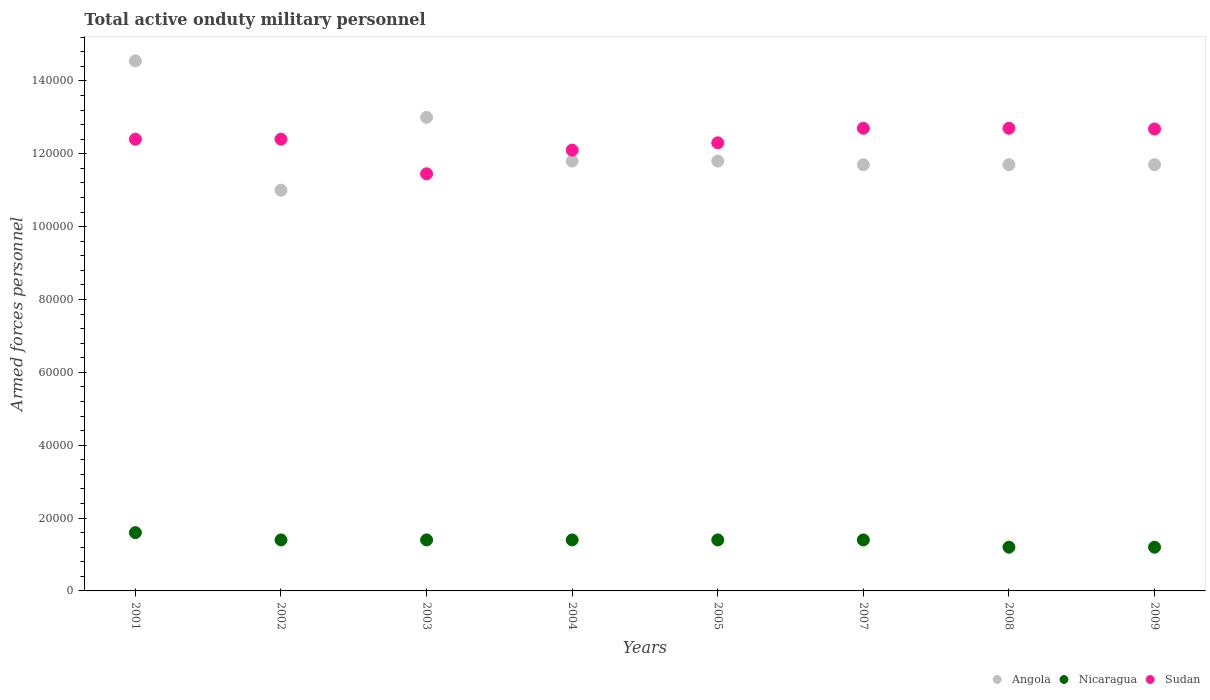How many different coloured dotlines are there?
Offer a very short reply. 3. Is the number of dotlines equal to the number of legend labels?
Offer a terse response. Yes. What is the number of armed forces personnel in Nicaragua in 2007?
Ensure brevity in your answer.  1.40e+04. Across all years, what is the maximum number of armed forces personnel in Sudan?
Provide a succinct answer. 1.27e+05. Across all years, what is the minimum number of armed forces personnel in Sudan?
Make the answer very short. 1.14e+05. In which year was the number of armed forces personnel in Angola maximum?
Provide a short and direct response. 2001. In which year was the number of armed forces personnel in Sudan minimum?
Offer a very short reply. 2003. What is the total number of armed forces personnel in Sudan in the graph?
Offer a terse response. 9.87e+05. What is the difference between the number of armed forces personnel in Sudan in 2001 and that in 2007?
Offer a very short reply. -3000. What is the difference between the number of armed forces personnel in Sudan in 2002 and the number of armed forces personnel in Nicaragua in 2001?
Ensure brevity in your answer.  1.08e+05. What is the average number of armed forces personnel in Sudan per year?
Keep it short and to the point. 1.23e+05. In the year 2003, what is the difference between the number of armed forces personnel in Sudan and number of armed forces personnel in Nicaragua?
Provide a short and direct response. 1.00e+05. What is the ratio of the number of armed forces personnel in Angola in 2003 to that in 2008?
Your response must be concise. 1.11. Is the number of armed forces personnel in Sudan in 2002 less than that in 2009?
Your response must be concise. Yes. Is the difference between the number of armed forces personnel in Sudan in 2005 and 2007 greater than the difference between the number of armed forces personnel in Nicaragua in 2005 and 2007?
Your answer should be compact. No. What is the difference between the highest and the lowest number of armed forces personnel in Sudan?
Your answer should be compact. 1.25e+04. Does the number of armed forces personnel in Nicaragua monotonically increase over the years?
Offer a terse response. No. Is the number of armed forces personnel in Nicaragua strictly greater than the number of armed forces personnel in Angola over the years?
Ensure brevity in your answer.  No. How many dotlines are there?
Provide a succinct answer. 3. How many years are there in the graph?
Your answer should be very brief. 8. What is the difference between two consecutive major ticks on the Y-axis?
Give a very brief answer. 2.00e+04. Are the values on the major ticks of Y-axis written in scientific E-notation?
Give a very brief answer. No. Does the graph contain any zero values?
Give a very brief answer. No. What is the title of the graph?
Make the answer very short. Total active onduty military personnel. What is the label or title of the X-axis?
Keep it short and to the point. Years. What is the label or title of the Y-axis?
Your answer should be compact. Armed forces personnel. What is the Armed forces personnel in Angola in 2001?
Your answer should be compact. 1.46e+05. What is the Armed forces personnel in Nicaragua in 2001?
Provide a short and direct response. 1.60e+04. What is the Armed forces personnel in Sudan in 2001?
Your answer should be compact. 1.24e+05. What is the Armed forces personnel in Angola in 2002?
Keep it short and to the point. 1.10e+05. What is the Armed forces personnel in Nicaragua in 2002?
Make the answer very short. 1.40e+04. What is the Armed forces personnel of Sudan in 2002?
Keep it short and to the point. 1.24e+05. What is the Armed forces personnel of Nicaragua in 2003?
Your response must be concise. 1.40e+04. What is the Armed forces personnel of Sudan in 2003?
Offer a very short reply. 1.14e+05. What is the Armed forces personnel in Angola in 2004?
Your answer should be very brief. 1.18e+05. What is the Armed forces personnel in Nicaragua in 2004?
Keep it short and to the point. 1.40e+04. What is the Armed forces personnel of Sudan in 2004?
Keep it short and to the point. 1.21e+05. What is the Armed forces personnel in Angola in 2005?
Offer a terse response. 1.18e+05. What is the Armed forces personnel of Nicaragua in 2005?
Your answer should be very brief. 1.40e+04. What is the Armed forces personnel of Sudan in 2005?
Offer a very short reply. 1.23e+05. What is the Armed forces personnel in Angola in 2007?
Provide a short and direct response. 1.17e+05. What is the Armed forces personnel of Nicaragua in 2007?
Keep it short and to the point. 1.40e+04. What is the Armed forces personnel in Sudan in 2007?
Offer a terse response. 1.27e+05. What is the Armed forces personnel of Angola in 2008?
Offer a terse response. 1.17e+05. What is the Armed forces personnel in Nicaragua in 2008?
Provide a succinct answer. 1.20e+04. What is the Armed forces personnel in Sudan in 2008?
Offer a terse response. 1.27e+05. What is the Armed forces personnel in Angola in 2009?
Offer a terse response. 1.17e+05. What is the Armed forces personnel in Nicaragua in 2009?
Ensure brevity in your answer.  1.20e+04. What is the Armed forces personnel of Sudan in 2009?
Keep it short and to the point. 1.27e+05. Across all years, what is the maximum Armed forces personnel of Angola?
Ensure brevity in your answer.  1.46e+05. Across all years, what is the maximum Armed forces personnel of Nicaragua?
Ensure brevity in your answer.  1.60e+04. Across all years, what is the maximum Armed forces personnel in Sudan?
Your answer should be very brief. 1.27e+05. Across all years, what is the minimum Armed forces personnel of Angola?
Your answer should be very brief. 1.10e+05. Across all years, what is the minimum Armed forces personnel in Nicaragua?
Provide a succinct answer. 1.20e+04. Across all years, what is the minimum Armed forces personnel of Sudan?
Your answer should be very brief. 1.14e+05. What is the total Armed forces personnel of Angola in the graph?
Your answer should be compact. 9.72e+05. What is the total Armed forces personnel in Nicaragua in the graph?
Your response must be concise. 1.10e+05. What is the total Armed forces personnel of Sudan in the graph?
Your answer should be compact. 9.87e+05. What is the difference between the Armed forces personnel in Angola in 2001 and that in 2002?
Provide a short and direct response. 3.55e+04. What is the difference between the Armed forces personnel in Angola in 2001 and that in 2003?
Keep it short and to the point. 1.55e+04. What is the difference between the Armed forces personnel in Sudan in 2001 and that in 2003?
Your answer should be compact. 9500. What is the difference between the Armed forces personnel of Angola in 2001 and that in 2004?
Provide a short and direct response. 2.75e+04. What is the difference between the Armed forces personnel of Nicaragua in 2001 and that in 2004?
Your answer should be very brief. 2000. What is the difference between the Armed forces personnel in Sudan in 2001 and that in 2004?
Give a very brief answer. 3000. What is the difference between the Armed forces personnel of Angola in 2001 and that in 2005?
Offer a terse response. 2.75e+04. What is the difference between the Armed forces personnel of Sudan in 2001 and that in 2005?
Offer a terse response. 1000. What is the difference between the Armed forces personnel in Angola in 2001 and that in 2007?
Your answer should be compact. 2.85e+04. What is the difference between the Armed forces personnel in Sudan in 2001 and that in 2007?
Provide a succinct answer. -3000. What is the difference between the Armed forces personnel in Angola in 2001 and that in 2008?
Give a very brief answer. 2.85e+04. What is the difference between the Armed forces personnel in Nicaragua in 2001 and that in 2008?
Provide a short and direct response. 4000. What is the difference between the Armed forces personnel in Sudan in 2001 and that in 2008?
Offer a terse response. -3000. What is the difference between the Armed forces personnel in Angola in 2001 and that in 2009?
Provide a succinct answer. 2.85e+04. What is the difference between the Armed forces personnel in Nicaragua in 2001 and that in 2009?
Offer a terse response. 4000. What is the difference between the Armed forces personnel of Sudan in 2001 and that in 2009?
Provide a succinct answer. -2800. What is the difference between the Armed forces personnel in Angola in 2002 and that in 2003?
Your response must be concise. -2.00e+04. What is the difference between the Armed forces personnel of Nicaragua in 2002 and that in 2003?
Provide a succinct answer. 0. What is the difference between the Armed forces personnel of Sudan in 2002 and that in 2003?
Make the answer very short. 9500. What is the difference between the Armed forces personnel in Angola in 2002 and that in 2004?
Your answer should be compact. -8000. What is the difference between the Armed forces personnel of Nicaragua in 2002 and that in 2004?
Keep it short and to the point. 0. What is the difference between the Armed forces personnel of Sudan in 2002 and that in 2004?
Your answer should be compact. 3000. What is the difference between the Armed forces personnel of Angola in 2002 and that in 2005?
Give a very brief answer. -8000. What is the difference between the Armed forces personnel of Sudan in 2002 and that in 2005?
Keep it short and to the point. 1000. What is the difference between the Armed forces personnel in Angola in 2002 and that in 2007?
Keep it short and to the point. -7000. What is the difference between the Armed forces personnel of Sudan in 2002 and that in 2007?
Provide a short and direct response. -3000. What is the difference between the Armed forces personnel of Angola in 2002 and that in 2008?
Your answer should be compact. -7000. What is the difference between the Armed forces personnel of Sudan in 2002 and that in 2008?
Ensure brevity in your answer.  -3000. What is the difference between the Armed forces personnel in Angola in 2002 and that in 2009?
Keep it short and to the point. -7000. What is the difference between the Armed forces personnel of Nicaragua in 2002 and that in 2009?
Provide a short and direct response. 2000. What is the difference between the Armed forces personnel in Sudan in 2002 and that in 2009?
Offer a terse response. -2800. What is the difference between the Armed forces personnel in Angola in 2003 and that in 2004?
Your response must be concise. 1.20e+04. What is the difference between the Armed forces personnel in Nicaragua in 2003 and that in 2004?
Ensure brevity in your answer.  0. What is the difference between the Armed forces personnel in Sudan in 2003 and that in 2004?
Ensure brevity in your answer.  -6500. What is the difference between the Armed forces personnel in Angola in 2003 and that in 2005?
Ensure brevity in your answer.  1.20e+04. What is the difference between the Armed forces personnel of Nicaragua in 2003 and that in 2005?
Provide a short and direct response. 0. What is the difference between the Armed forces personnel in Sudan in 2003 and that in 2005?
Your answer should be compact. -8500. What is the difference between the Armed forces personnel of Angola in 2003 and that in 2007?
Give a very brief answer. 1.30e+04. What is the difference between the Armed forces personnel of Nicaragua in 2003 and that in 2007?
Your answer should be very brief. 0. What is the difference between the Armed forces personnel of Sudan in 2003 and that in 2007?
Your answer should be very brief. -1.25e+04. What is the difference between the Armed forces personnel in Angola in 2003 and that in 2008?
Your response must be concise. 1.30e+04. What is the difference between the Armed forces personnel of Nicaragua in 2003 and that in 2008?
Provide a short and direct response. 2000. What is the difference between the Armed forces personnel in Sudan in 2003 and that in 2008?
Make the answer very short. -1.25e+04. What is the difference between the Armed forces personnel of Angola in 2003 and that in 2009?
Offer a very short reply. 1.30e+04. What is the difference between the Armed forces personnel of Sudan in 2003 and that in 2009?
Your answer should be very brief. -1.23e+04. What is the difference between the Armed forces personnel in Angola in 2004 and that in 2005?
Give a very brief answer. 0. What is the difference between the Armed forces personnel in Nicaragua in 2004 and that in 2005?
Keep it short and to the point. 0. What is the difference between the Armed forces personnel of Sudan in 2004 and that in 2005?
Your response must be concise. -2000. What is the difference between the Armed forces personnel in Angola in 2004 and that in 2007?
Provide a succinct answer. 1000. What is the difference between the Armed forces personnel in Sudan in 2004 and that in 2007?
Provide a succinct answer. -6000. What is the difference between the Armed forces personnel in Sudan in 2004 and that in 2008?
Offer a terse response. -6000. What is the difference between the Armed forces personnel in Angola in 2004 and that in 2009?
Your answer should be very brief. 1000. What is the difference between the Armed forces personnel of Sudan in 2004 and that in 2009?
Your answer should be very brief. -5800. What is the difference between the Armed forces personnel in Nicaragua in 2005 and that in 2007?
Keep it short and to the point. 0. What is the difference between the Armed forces personnel of Sudan in 2005 and that in 2007?
Offer a terse response. -4000. What is the difference between the Armed forces personnel in Nicaragua in 2005 and that in 2008?
Offer a very short reply. 2000. What is the difference between the Armed forces personnel in Sudan in 2005 and that in 2008?
Offer a terse response. -4000. What is the difference between the Armed forces personnel of Nicaragua in 2005 and that in 2009?
Provide a succinct answer. 2000. What is the difference between the Armed forces personnel of Sudan in 2005 and that in 2009?
Give a very brief answer. -3800. What is the difference between the Armed forces personnel in Angola in 2007 and that in 2008?
Your answer should be compact. 0. What is the difference between the Armed forces personnel in Sudan in 2007 and that in 2008?
Offer a very short reply. 0. What is the difference between the Armed forces personnel of Nicaragua in 2007 and that in 2009?
Offer a terse response. 2000. What is the difference between the Armed forces personnel in Sudan in 2007 and that in 2009?
Offer a very short reply. 200. What is the difference between the Armed forces personnel of Nicaragua in 2008 and that in 2009?
Your response must be concise. 0. What is the difference between the Armed forces personnel in Angola in 2001 and the Armed forces personnel in Nicaragua in 2002?
Provide a short and direct response. 1.32e+05. What is the difference between the Armed forces personnel in Angola in 2001 and the Armed forces personnel in Sudan in 2002?
Offer a very short reply. 2.15e+04. What is the difference between the Armed forces personnel in Nicaragua in 2001 and the Armed forces personnel in Sudan in 2002?
Offer a terse response. -1.08e+05. What is the difference between the Armed forces personnel in Angola in 2001 and the Armed forces personnel in Nicaragua in 2003?
Your answer should be very brief. 1.32e+05. What is the difference between the Armed forces personnel in Angola in 2001 and the Armed forces personnel in Sudan in 2003?
Provide a succinct answer. 3.10e+04. What is the difference between the Armed forces personnel of Nicaragua in 2001 and the Armed forces personnel of Sudan in 2003?
Provide a succinct answer. -9.85e+04. What is the difference between the Armed forces personnel of Angola in 2001 and the Armed forces personnel of Nicaragua in 2004?
Your response must be concise. 1.32e+05. What is the difference between the Armed forces personnel of Angola in 2001 and the Armed forces personnel of Sudan in 2004?
Make the answer very short. 2.45e+04. What is the difference between the Armed forces personnel in Nicaragua in 2001 and the Armed forces personnel in Sudan in 2004?
Your response must be concise. -1.05e+05. What is the difference between the Armed forces personnel in Angola in 2001 and the Armed forces personnel in Nicaragua in 2005?
Keep it short and to the point. 1.32e+05. What is the difference between the Armed forces personnel in Angola in 2001 and the Armed forces personnel in Sudan in 2005?
Your response must be concise. 2.25e+04. What is the difference between the Armed forces personnel in Nicaragua in 2001 and the Armed forces personnel in Sudan in 2005?
Offer a terse response. -1.07e+05. What is the difference between the Armed forces personnel of Angola in 2001 and the Armed forces personnel of Nicaragua in 2007?
Ensure brevity in your answer.  1.32e+05. What is the difference between the Armed forces personnel in Angola in 2001 and the Armed forces personnel in Sudan in 2007?
Your response must be concise. 1.85e+04. What is the difference between the Armed forces personnel in Nicaragua in 2001 and the Armed forces personnel in Sudan in 2007?
Your answer should be very brief. -1.11e+05. What is the difference between the Armed forces personnel in Angola in 2001 and the Armed forces personnel in Nicaragua in 2008?
Give a very brief answer. 1.34e+05. What is the difference between the Armed forces personnel of Angola in 2001 and the Armed forces personnel of Sudan in 2008?
Provide a short and direct response. 1.85e+04. What is the difference between the Armed forces personnel in Nicaragua in 2001 and the Armed forces personnel in Sudan in 2008?
Your response must be concise. -1.11e+05. What is the difference between the Armed forces personnel of Angola in 2001 and the Armed forces personnel of Nicaragua in 2009?
Offer a terse response. 1.34e+05. What is the difference between the Armed forces personnel in Angola in 2001 and the Armed forces personnel in Sudan in 2009?
Your response must be concise. 1.87e+04. What is the difference between the Armed forces personnel in Nicaragua in 2001 and the Armed forces personnel in Sudan in 2009?
Give a very brief answer. -1.11e+05. What is the difference between the Armed forces personnel in Angola in 2002 and the Armed forces personnel in Nicaragua in 2003?
Give a very brief answer. 9.60e+04. What is the difference between the Armed forces personnel in Angola in 2002 and the Armed forces personnel in Sudan in 2003?
Give a very brief answer. -4500. What is the difference between the Armed forces personnel of Nicaragua in 2002 and the Armed forces personnel of Sudan in 2003?
Keep it short and to the point. -1.00e+05. What is the difference between the Armed forces personnel of Angola in 2002 and the Armed forces personnel of Nicaragua in 2004?
Ensure brevity in your answer.  9.60e+04. What is the difference between the Armed forces personnel of Angola in 2002 and the Armed forces personnel of Sudan in 2004?
Provide a succinct answer. -1.10e+04. What is the difference between the Armed forces personnel of Nicaragua in 2002 and the Armed forces personnel of Sudan in 2004?
Your answer should be very brief. -1.07e+05. What is the difference between the Armed forces personnel of Angola in 2002 and the Armed forces personnel of Nicaragua in 2005?
Provide a short and direct response. 9.60e+04. What is the difference between the Armed forces personnel in Angola in 2002 and the Armed forces personnel in Sudan in 2005?
Provide a short and direct response. -1.30e+04. What is the difference between the Armed forces personnel in Nicaragua in 2002 and the Armed forces personnel in Sudan in 2005?
Your answer should be very brief. -1.09e+05. What is the difference between the Armed forces personnel of Angola in 2002 and the Armed forces personnel of Nicaragua in 2007?
Make the answer very short. 9.60e+04. What is the difference between the Armed forces personnel in Angola in 2002 and the Armed forces personnel in Sudan in 2007?
Ensure brevity in your answer.  -1.70e+04. What is the difference between the Armed forces personnel of Nicaragua in 2002 and the Armed forces personnel of Sudan in 2007?
Provide a succinct answer. -1.13e+05. What is the difference between the Armed forces personnel of Angola in 2002 and the Armed forces personnel of Nicaragua in 2008?
Provide a short and direct response. 9.80e+04. What is the difference between the Armed forces personnel in Angola in 2002 and the Armed forces personnel in Sudan in 2008?
Provide a succinct answer. -1.70e+04. What is the difference between the Armed forces personnel of Nicaragua in 2002 and the Armed forces personnel of Sudan in 2008?
Ensure brevity in your answer.  -1.13e+05. What is the difference between the Armed forces personnel in Angola in 2002 and the Armed forces personnel in Nicaragua in 2009?
Keep it short and to the point. 9.80e+04. What is the difference between the Armed forces personnel of Angola in 2002 and the Armed forces personnel of Sudan in 2009?
Ensure brevity in your answer.  -1.68e+04. What is the difference between the Armed forces personnel in Nicaragua in 2002 and the Armed forces personnel in Sudan in 2009?
Your response must be concise. -1.13e+05. What is the difference between the Armed forces personnel in Angola in 2003 and the Armed forces personnel in Nicaragua in 2004?
Ensure brevity in your answer.  1.16e+05. What is the difference between the Armed forces personnel in Angola in 2003 and the Armed forces personnel in Sudan in 2004?
Ensure brevity in your answer.  9000. What is the difference between the Armed forces personnel in Nicaragua in 2003 and the Armed forces personnel in Sudan in 2004?
Provide a short and direct response. -1.07e+05. What is the difference between the Armed forces personnel in Angola in 2003 and the Armed forces personnel in Nicaragua in 2005?
Make the answer very short. 1.16e+05. What is the difference between the Armed forces personnel of Angola in 2003 and the Armed forces personnel of Sudan in 2005?
Make the answer very short. 7000. What is the difference between the Armed forces personnel in Nicaragua in 2003 and the Armed forces personnel in Sudan in 2005?
Your response must be concise. -1.09e+05. What is the difference between the Armed forces personnel in Angola in 2003 and the Armed forces personnel in Nicaragua in 2007?
Your response must be concise. 1.16e+05. What is the difference between the Armed forces personnel in Angola in 2003 and the Armed forces personnel in Sudan in 2007?
Provide a succinct answer. 3000. What is the difference between the Armed forces personnel of Nicaragua in 2003 and the Armed forces personnel of Sudan in 2007?
Your answer should be very brief. -1.13e+05. What is the difference between the Armed forces personnel of Angola in 2003 and the Armed forces personnel of Nicaragua in 2008?
Ensure brevity in your answer.  1.18e+05. What is the difference between the Armed forces personnel of Angola in 2003 and the Armed forces personnel of Sudan in 2008?
Offer a very short reply. 3000. What is the difference between the Armed forces personnel of Nicaragua in 2003 and the Armed forces personnel of Sudan in 2008?
Make the answer very short. -1.13e+05. What is the difference between the Armed forces personnel of Angola in 2003 and the Armed forces personnel of Nicaragua in 2009?
Your answer should be very brief. 1.18e+05. What is the difference between the Armed forces personnel in Angola in 2003 and the Armed forces personnel in Sudan in 2009?
Give a very brief answer. 3200. What is the difference between the Armed forces personnel of Nicaragua in 2003 and the Armed forces personnel of Sudan in 2009?
Keep it short and to the point. -1.13e+05. What is the difference between the Armed forces personnel of Angola in 2004 and the Armed forces personnel of Nicaragua in 2005?
Your response must be concise. 1.04e+05. What is the difference between the Armed forces personnel in Angola in 2004 and the Armed forces personnel in Sudan in 2005?
Your response must be concise. -5000. What is the difference between the Armed forces personnel of Nicaragua in 2004 and the Armed forces personnel of Sudan in 2005?
Keep it short and to the point. -1.09e+05. What is the difference between the Armed forces personnel of Angola in 2004 and the Armed forces personnel of Nicaragua in 2007?
Provide a succinct answer. 1.04e+05. What is the difference between the Armed forces personnel in Angola in 2004 and the Armed forces personnel in Sudan in 2007?
Keep it short and to the point. -9000. What is the difference between the Armed forces personnel in Nicaragua in 2004 and the Armed forces personnel in Sudan in 2007?
Provide a short and direct response. -1.13e+05. What is the difference between the Armed forces personnel of Angola in 2004 and the Armed forces personnel of Nicaragua in 2008?
Keep it short and to the point. 1.06e+05. What is the difference between the Armed forces personnel of Angola in 2004 and the Armed forces personnel of Sudan in 2008?
Provide a short and direct response. -9000. What is the difference between the Armed forces personnel in Nicaragua in 2004 and the Armed forces personnel in Sudan in 2008?
Give a very brief answer. -1.13e+05. What is the difference between the Armed forces personnel in Angola in 2004 and the Armed forces personnel in Nicaragua in 2009?
Offer a terse response. 1.06e+05. What is the difference between the Armed forces personnel of Angola in 2004 and the Armed forces personnel of Sudan in 2009?
Provide a succinct answer. -8800. What is the difference between the Armed forces personnel of Nicaragua in 2004 and the Armed forces personnel of Sudan in 2009?
Offer a very short reply. -1.13e+05. What is the difference between the Armed forces personnel of Angola in 2005 and the Armed forces personnel of Nicaragua in 2007?
Ensure brevity in your answer.  1.04e+05. What is the difference between the Armed forces personnel in Angola in 2005 and the Armed forces personnel in Sudan in 2007?
Give a very brief answer. -9000. What is the difference between the Armed forces personnel of Nicaragua in 2005 and the Armed forces personnel of Sudan in 2007?
Provide a succinct answer. -1.13e+05. What is the difference between the Armed forces personnel in Angola in 2005 and the Armed forces personnel in Nicaragua in 2008?
Provide a short and direct response. 1.06e+05. What is the difference between the Armed forces personnel in Angola in 2005 and the Armed forces personnel in Sudan in 2008?
Ensure brevity in your answer.  -9000. What is the difference between the Armed forces personnel in Nicaragua in 2005 and the Armed forces personnel in Sudan in 2008?
Keep it short and to the point. -1.13e+05. What is the difference between the Armed forces personnel in Angola in 2005 and the Armed forces personnel in Nicaragua in 2009?
Your answer should be very brief. 1.06e+05. What is the difference between the Armed forces personnel in Angola in 2005 and the Armed forces personnel in Sudan in 2009?
Keep it short and to the point. -8800. What is the difference between the Armed forces personnel of Nicaragua in 2005 and the Armed forces personnel of Sudan in 2009?
Ensure brevity in your answer.  -1.13e+05. What is the difference between the Armed forces personnel in Angola in 2007 and the Armed forces personnel in Nicaragua in 2008?
Offer a very short reply. 1.05e+05. What is the difference between the Armed forces personnel in Nicaragua in 2007 and the Armed forces personnel in Sudan in 2008?
Your answer should be compact. -1.13e+05. What is the difference between the Armed forces personnel of Angola in 2007 and the Armed forces personnel of Nicaragua in 2009?
Offer a terse response. 1.05e+05. What is the difference between the Armed forces personnel in Angola in 2007 and the Armed forces personnel in Sudan in 2009?
Keep it short and to the point. -9800. What is the difference between the Armed forces personnel of Nicaragua in 2007 and the Armed forces personnel of Sudan in 2009?
Your answer should be very brief. -1.13e+05. What is the difference between the Armed forces personnel in Angola in 2008 and the Armed forces personnel in Nicaragua in 2009?
Provide a short and direct response. 1.05e+05. What is the difference between the Armed forces personnel of Angola in 2008 and the Armed forces personnel of Sudan in 2009?
Ensure brevity in your answer.  -9800. What is the difference between the Armed forces personnel in Nicaragua in 2008 and the Armed forces personnel in Sudan in 2009?
Provide a short and direct response. -1.15e+05. What is the average Armed forces personnel of Angola per year?
Provide a short and direct response. 1.22e+05. What is the average Armed forces personnel in Nicaragua per year?
Provide a short and direct response. 1.38e+04. What is the average Armed forces personnel in Sudan per year?
Provide a succinct answer. 1.23e+05. In the year 2001, what is the difference between the Armed forces personnel in Angola and Armed forces personnel in Nicaragua?
Offer a terse response. 1.30e+05. In the year 2001, what is the difference between the Armed forces personnel of Angola and Armed forces personnel of Sudan?
Offer a terse response. 2.15e+04. In the year 2001, what is the difference between the Armed forces personnel of Nicaragua and Armed forces personnel of Sudan?
Offer a very short reply. -1.08e+05. In the year 2002, what is the difference between the Armed forces personnel of Angola and Armed forces personnel of Nicaragua?
Provide a short and direct response. 9.60e+04. In the year 2002, what is the difference between the Armed forces personnel of Angola and Armed forces personnel of Sudan?
Give a very brief answer. -1.40e+04. In the year 2002, what is the difference between the Armed forces personnel in Nicaragua and Armed forces personnel in Sudan?
Offer a terse response. -1.10e+05. In the year 2003, what is the difference between the Armed forces personnel of Angola and Armed forces personnel of Nicaragua?
Your answer should be compact. 1.16e+05. In the year 2003, what is the difference between the Armed forces personnel of Angola and Armed forces personnel of Sudan?
Give a very brief answer. 1.55e+04. In the year 2003, what is the difference between the Armed forces personnel of Nicaragua and Armed forces personnel of Sudan?
Give a very brief answer. -1.00e+05. In the year 2004, what is the difference between the Armed forces personnel of Angola and Armed forces personnel of Nicaragua?
Make the answer very short. 1.04e+05. In the year 2004, what is the difference between the Armed forces personnel of Angola and Armed forces personnel of Sudan?
Your answer should be very brief. -3000. In the year 2004, what is the difference between the Armed forces personnel in Nicaragua and Armed forces personnel in Sudan?
Ensure brevity in your answer.  -1.07e+05. In the year 2005, what is the difference between the Armed forces personnel of Angola and Armed forces personnel of Nicaragua?
Your answer should be very brief. 1.04e+05. In the year 2005, what is the difference between the Armed forces personnel in Angola and Armed forces personnel in Sudan?
Give a very brief answer. -5000. In the year 2005, what is the difference between the Armed forces personnel of Nicaragua and Armed forces personnel of Sudan?
Your answer should be compact. -1.09e+05. In the year 2007, what is the difference between the Armed forces personnel of Angola and Armed forces personnel of Nicaragua?
Offer a terse response. 1.03e+05. In the year 2007, what is the difference between the Armed forces personnel of Angola and Armed forces personnel of Sudan?
Your answer should be compact. -10000. In the year 2007, what is the difference between the Armed forces personnel of Nicaragua and Armed forces personnel of Sudan?
Provide a succinct answer. -1.13e+05. In the year 2008, what is the difference between the Armed forces personnel in Angola and Armed forces personnel in Nicaragua?
Ensure brevity in your answer.  1.05e+05. In the year 2008, what is the difference between the Armed forces personnel of Nicaragua and Armed forces personnel of Sudan?
Keep it short and to the point. -1.15e+05. In the year 2009, what is the difference between the Armed forces personnel of Angola and Armed forces personnel of Nicaragua?
Offer a very short reply. 1.05e+05. In the year 2009, what is the difference between the Armed forces personnel of Angola and Armed forces personnel of Sudan?
Provide a succinct answer. -9800. In the year 2009, what is the difference between the Armed forces personnel of Nicaragua and Armed forces personnel of Sudan?
Provide a short and direct response. -1.15e+05. What is the ratio of the Armed forces personnel in Angola in 2001 to that in 2002?
Keep it short and to the point. 1.32. What is the ratio of the Armed forces personnel in Sudan in 2001 to that in 2002?
Make the answer very short. 1. What is the ratio of the Armed forces personnel of Angola in 2001 to that in 2003?
Your response must be concise. 1.12. What is the ratio of the Armed forces personnel in Nicaragua in 2001 to that in 2003?
Provide a succinct answer. 1.14. What is the ratio of the Armed forces personnel of Sudan in 2001 to that in 2003?
Give a very brief answer. 1.08. What is the ratio of the Armed forces personnel in Angola in 2001 to that in 2004?
Provide a short and direct response. 1.23. What is the ratio of the Armed forces personnel in Nicaragua in 2001 to that in 2004?
Provide a short and direct response. 1.14. What is the ratio of the Armed forces personnel of Sudan in 2001 to that in 2004?
Your answer should be very brief. 1.02. What is the ratio of the Armed forces personnel of Angola in 2001 to that in 2005?
Provide a short and direct response. 1.23. What is the ratio of the Armed forces personnel of Sudan in 2001 to that in 2005?
Your answer should be compact. 1.01. What is the ratio of the Armed forces personnel in Angola in 2001 to that in 2007?
Provide a succinct answer. 1.24. What is the ratio of the Armed forces personnel in Nicaragua in 2001 to that in 2007?
Keep it short and to the point. 1.14. What is the ratio of the Armed forces personnel of Sudan in 2001 to that in 2007?
Provide a short and direct response. 0.98. What is the ratio of the Armed forces personnel of Angola in 2001 to that in 2008?
Keep it short and to the point. 1.24. What is the ratio of the Armed forces personnel in Nicaragua in 2001 to that in 2008?
Your answer should be compact. 1.33. What is the ratio of the Armed forces personnel in Sudan in 2001 to that in 2008?
Your answer should be compact. 0.98. What is the ratio of the Armed forces personnel in Angola in 2001 to that in 2009?
Your answer should be compact. 1.24. What is the ratio of the Armed forces personnel in Sudan in 2001 to that in 2009?
Make the answer very short. 0.98. What is the ratio of the Armed forces personnel in Angola in 2002 to that in 2003?
Your answer should be very brief. 0.85. What is the ratio of the Armed forces personnel of Nicaragua in 2002 to that in 2003?
Make the answer very short. 1. What is the ratio of the Armed forces personnel in Sudan in 2002 to that in 2003?
Ensure brevity in your answer.  1.08. What is the ratio of the Armed forces personnel of Angola in 2002 to that in 2004?
Provide a short and direct response. 0.93. What is the ratio of the Armed forces personnel in Nicaragua in 2002 to that in 2004?
Ensure brevity in your answer.  1. What is the ratio of the Armed forces personnel in Sudan in 2002 to that in 2004?
Ensure brevity in your answer.  1.02. What is the ratio of the Armed forces personnel of Angola in 2002 to that in 2005?
Offer a terse response. 0.93. What is the ratio of the Armed forces personnel in Nicaragua in 2002 to that in 2005?
Offer a terse response. 1. What is the ratio of the Armed forces personnel in Angola in 2002 to that in 2007?
Your response must be concise. 0.94. What is the ratio of the Armed forces personnel of Sudan in 2002 to that in 2007?
Provide a short and direct response. 0.98. What is the ratio of the Armed forces personnel in Angola in 2002 to that in 2008?
Your response must be concise. 0.94. What is the ratio of the Armed forces personnel in Sudan in 2002 to that in 2008?
Provide a short and direct response. 0.98. What is the ratio of the Armed forces personnel of Angola in 2002 to that in 2009?
Your answer should be very brief. 0.94. What is the ratio of the Armed forces personnel of Nicaragua in 2002 to that in 2009?
Make the answer very short. 1.17. What is the ratio of the Armed forces personnel of Sudan in 2002 to that in 2009?
Offer a terse response. 0.98. What is the ratio of the Armed forces personnel of Angola in 2003 to that in 2004?
Provide a short and direct response. 1.1. What is the ratio of the Armed forces personnel in Sudan in 2003 to that in 2004?
Make the answer very short. 0.95. What is the ratio of the Armed forces personnel in Angola in 2003 to that in 2005?
Offer a very short reply. 1.1. What is the ratio of the Armed forces personnel of Nicaragua in 2003 to that in 2005?
Keep it short and to the point. 1. What is the ratio of the Armed forces personnel in Sudan in 2003 to that in 2005?
Your answer should be very brief. 0.93. What is the ratio of the Armed forces personnel of Sudan in 2003 to that in 2007?
Provide a short and direct response. 0.9. What is the ratio of the Armed forces personnel in Sudan in 2003 to that in 2008?
Provide a succinct answer. 0.9. What is the ratio of the Armed forces personnel in Sudan in 2003 to that in 2009?
Offer a terse response. 0.9. What is the ratio of the Armed forces personnel in Sudan in 2004 to that in 2005?
Your response must be concise. 0.98. What is the ratio of the Armed forces personnel of Angola in 2004 to that in 2007?
Provide a short and direct response. 1.01. What is the ratio of the Armed forces personnel of Sudan in 2004 to that in 2007?
Your answer should be compact. 0.95. What is the ratio of the Armed forces personnel of Angola in 2004 to that in 2008?
Give a very brief answer. 1.01. What is the ratio of the Armed forces personnel in Sudan in 2004 to that in 2008?
Your response must be concise. 0.95. What is the ratio of the Armed forces personnel in Angola in 2004 to that in 2009?
Your response must be concise. 1.01. What is the ratio of the Armed forces personnel in Sudan in 2004 to that in 2009?
Your answer should be very brief. 0.95. What is the ratio of the Armed forces personnel of Angola in 2005 to that in 2007?
Ensure brevity in your answer.  1.01. What is the ratio of the Armed forces personnel of Nicaragua in 2005 to that in 2007?
Provide a short and direct response. 1. What is the ratio of the Armed forces personnel of Sudan in 2005 to that in 2007?
Make the answer very short. 0.97. What is the ratio of the Armed forces personnel in Angola in 2005 to that in 2008?
Offer a terse response. 1.01. What is the ratio of the Armed forces personnel in Nicaragua in 2005 to that in 2008?
Your answer should be compact. 1.17. What is the ratio of the Armed forces personnel in Sudan in 2005 to that in 2008?
Your response must be concise. 0.97. What is the ratio of the Armed forces personnel of Angola in 2005 to that in 2009?
Keep it short and to the point. 1.01. What is the ratio of the Armed forces personnel in Nicaragua in 2005 to that in 2009?
Provide a short and direct response. 1.17. What is the ratio of the Armed forces personnel of Sudan in 2005 to that in 2009?
Give a very brief answer. 0.97. What is the ratio of the Armed forces personnel of Angola in 2007 to that in 2008?
Provide a succinct answer. 1. What is the ratio of the Armed forces personnel of Nicaragua in 2007 to that in 2008?
Your response must be concise. 1.17. What is the ratio of the Armed forces personnel in Sudan in 2007 to that in 2008?
Keep it short and to the point. 1. What is the ratio of the Armed forces personnel of Angola in 2007 to that in 2009?
Give a very brief answer. 1. What is the ratio of the Armed forces personnel in Nicaragua in 2007 to that in 2009?
Your answer should be compact. 1.17. What is the ratio of the Armed forces personnel in Sudan in 2007 to that in 2009?
Your answer should be very brief. 1. What is the ratio of the Armed forces personnel in Nicaragua in 2008 to that in 2009?
Offer a terse response. 1. What is the ratio of the Armed forces personnel in Sudan in 2008 to that in 2009?
Keep it short and to the point. 1. What is the difference between the highest and the second highest Armed forces personnel in Angola?
Your answer should be compact. 1.55e+04. What is the difference between the highest and the second highest Armed forces personnel of Nicaragua?
Ensure brevity in your answer.  2000. What is the difference between the highest and the lowest Armed forces personnel in Angola?
Your response must be concise. 3.55e+04. What is the difference between the highest and the lowest Armed forces personnel in Nicaragua?
Your response must be concise. 4000. What is the difference between the highest and the lowest Armed forces personnel of Sudan?
Keep it short and to the point. 1.25e+04. 